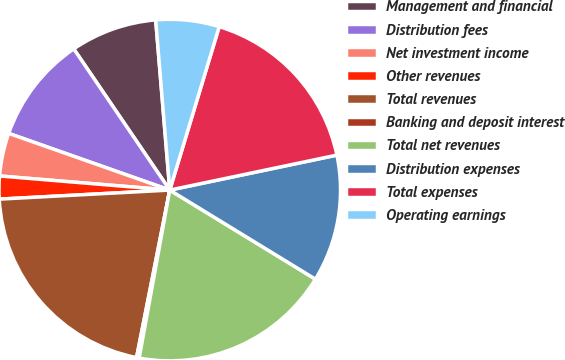Convert chart. <chart><loc_0><loc_0><loc_500><loc_500><pie_chart><fcel>Management and financial<fcel>Distribution fees<fcel>Net investment income<fcel>Other revenues<fcel>Total revenues<fcel>Banking and deposit interest<fcel>Total net revenues<fcel>Distribution expenses<fcel>Total expenses<fcel>Operating earnings<nl><fcel>8.19%<fcel>10.11%<fcel>4.07%<fcel>2.16%<fcel>21.04%<fcel>0.25%<fcel>19.13%<fcel>12.02%<fcel>17.04%<fcel>5.99%<nl></chart> 